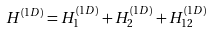Convert formula to latex. <formula><loc_0><loc_0><loc_500><loc_500>H ^ { ( 1 D ) } = H ^ { ( 1 D ) } _ { 1 } + H ^ { ( 1 D ) } _ { 2 } + H ^ { ( 1 D ) } _ { 1 2 }</formula> 